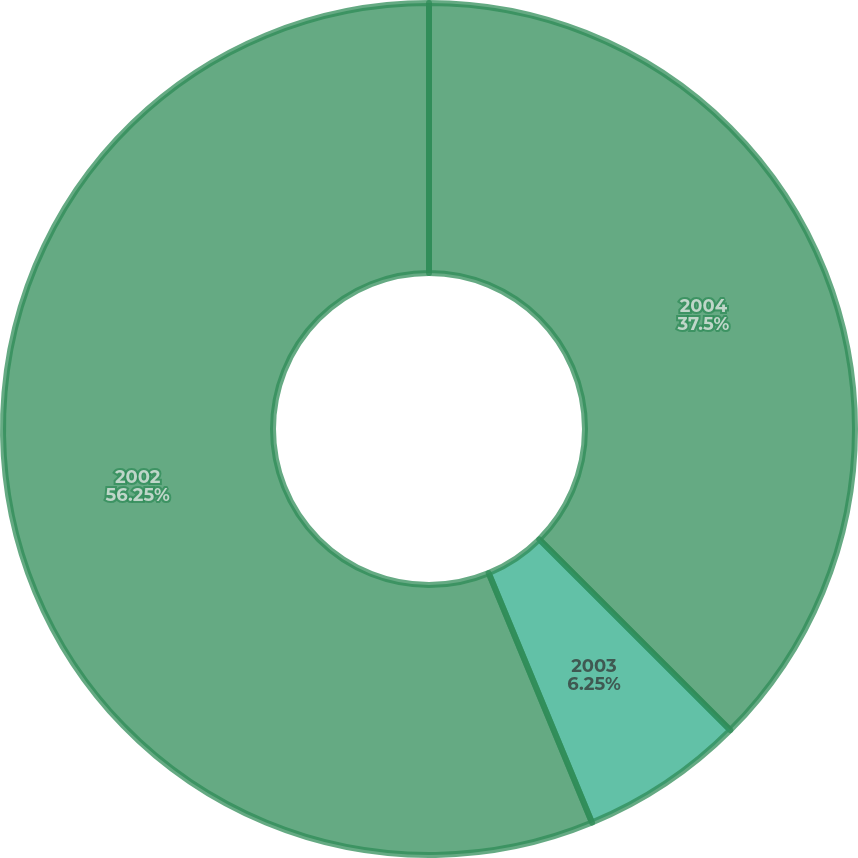<chart> <loc_0><loc_0><loc_500><loc_500><pie_chart><fcel>2004<fcel>2003<fcel>2002<nl><fcel>37.5%<fcel>6.25%<fcel>56.25%<nl></chart> 